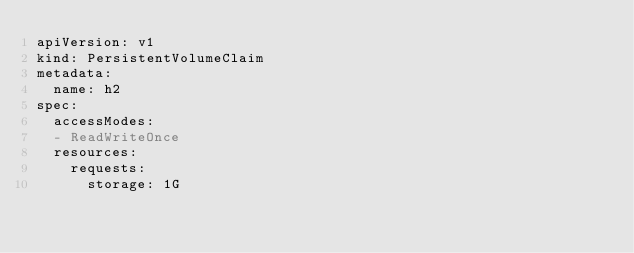Convert code to text. <code><loc_0><loc_0><loc_500><loc_500><_YAML_>apiVersion: v1
kind: PersistentVolumeClaim
metadata:
  name: h2
spec:
  accessModes:
  - ReadWriteOnce
  resources:
    requests:
      storage: 1G
</code> 